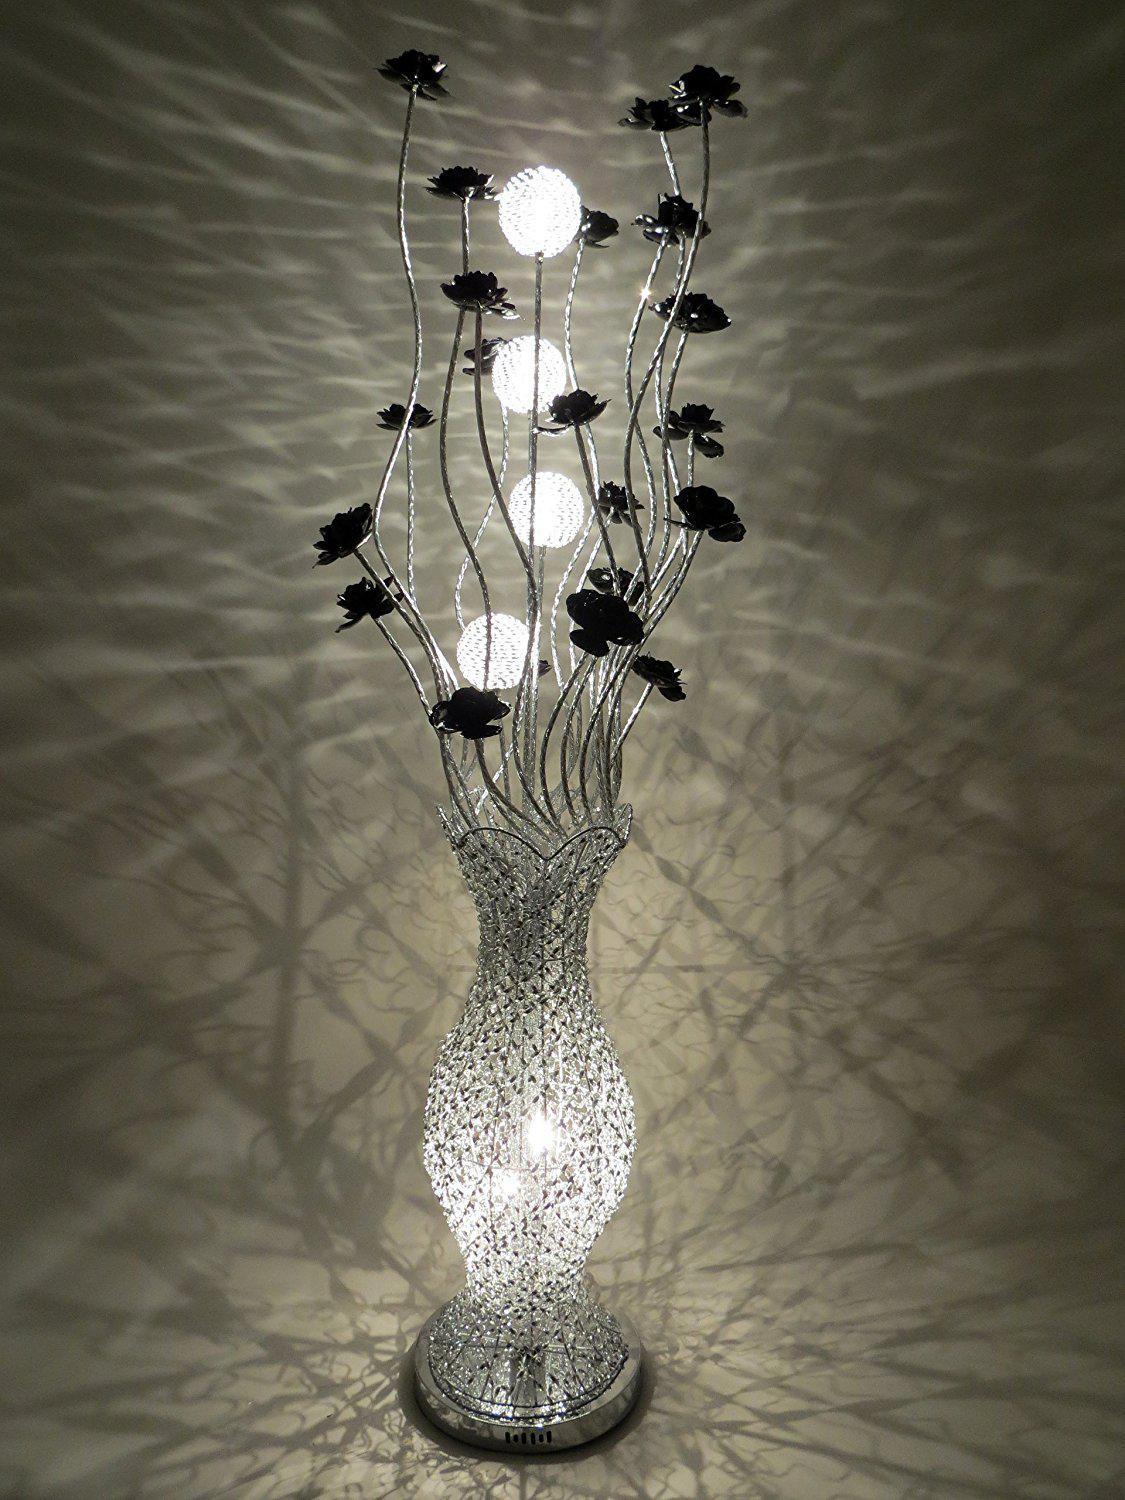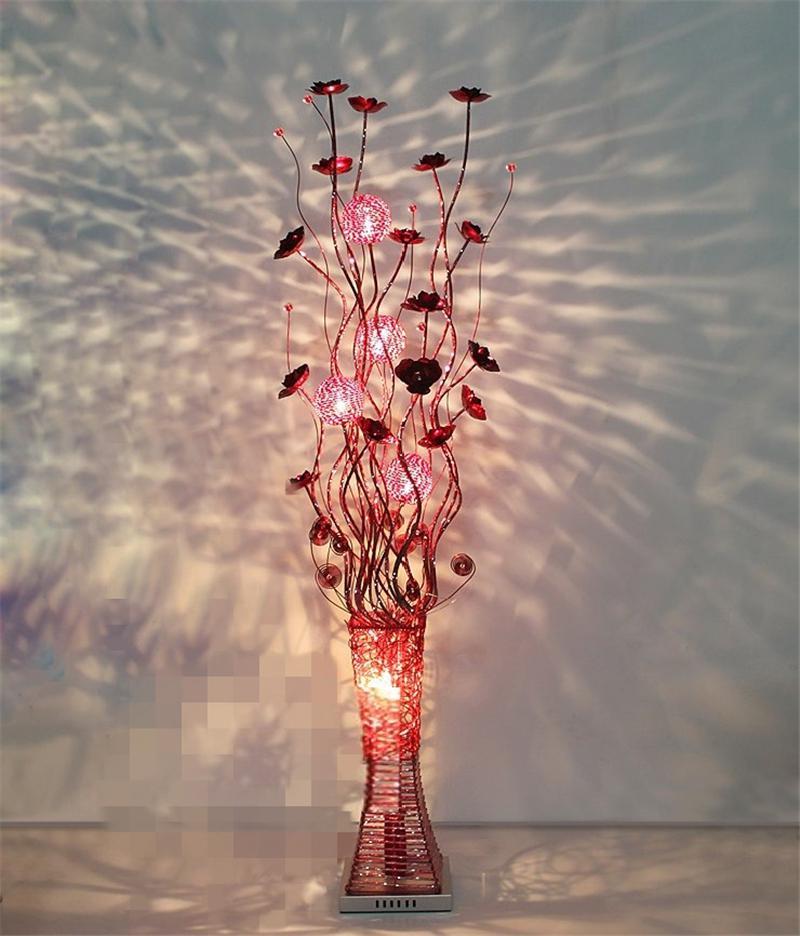The first image is the image on the left, the second image is the image on the right. For the images displayed, is the sentence "There is a silver lamp with white lights in the right image." factually correct? Answer yes or no. No. 